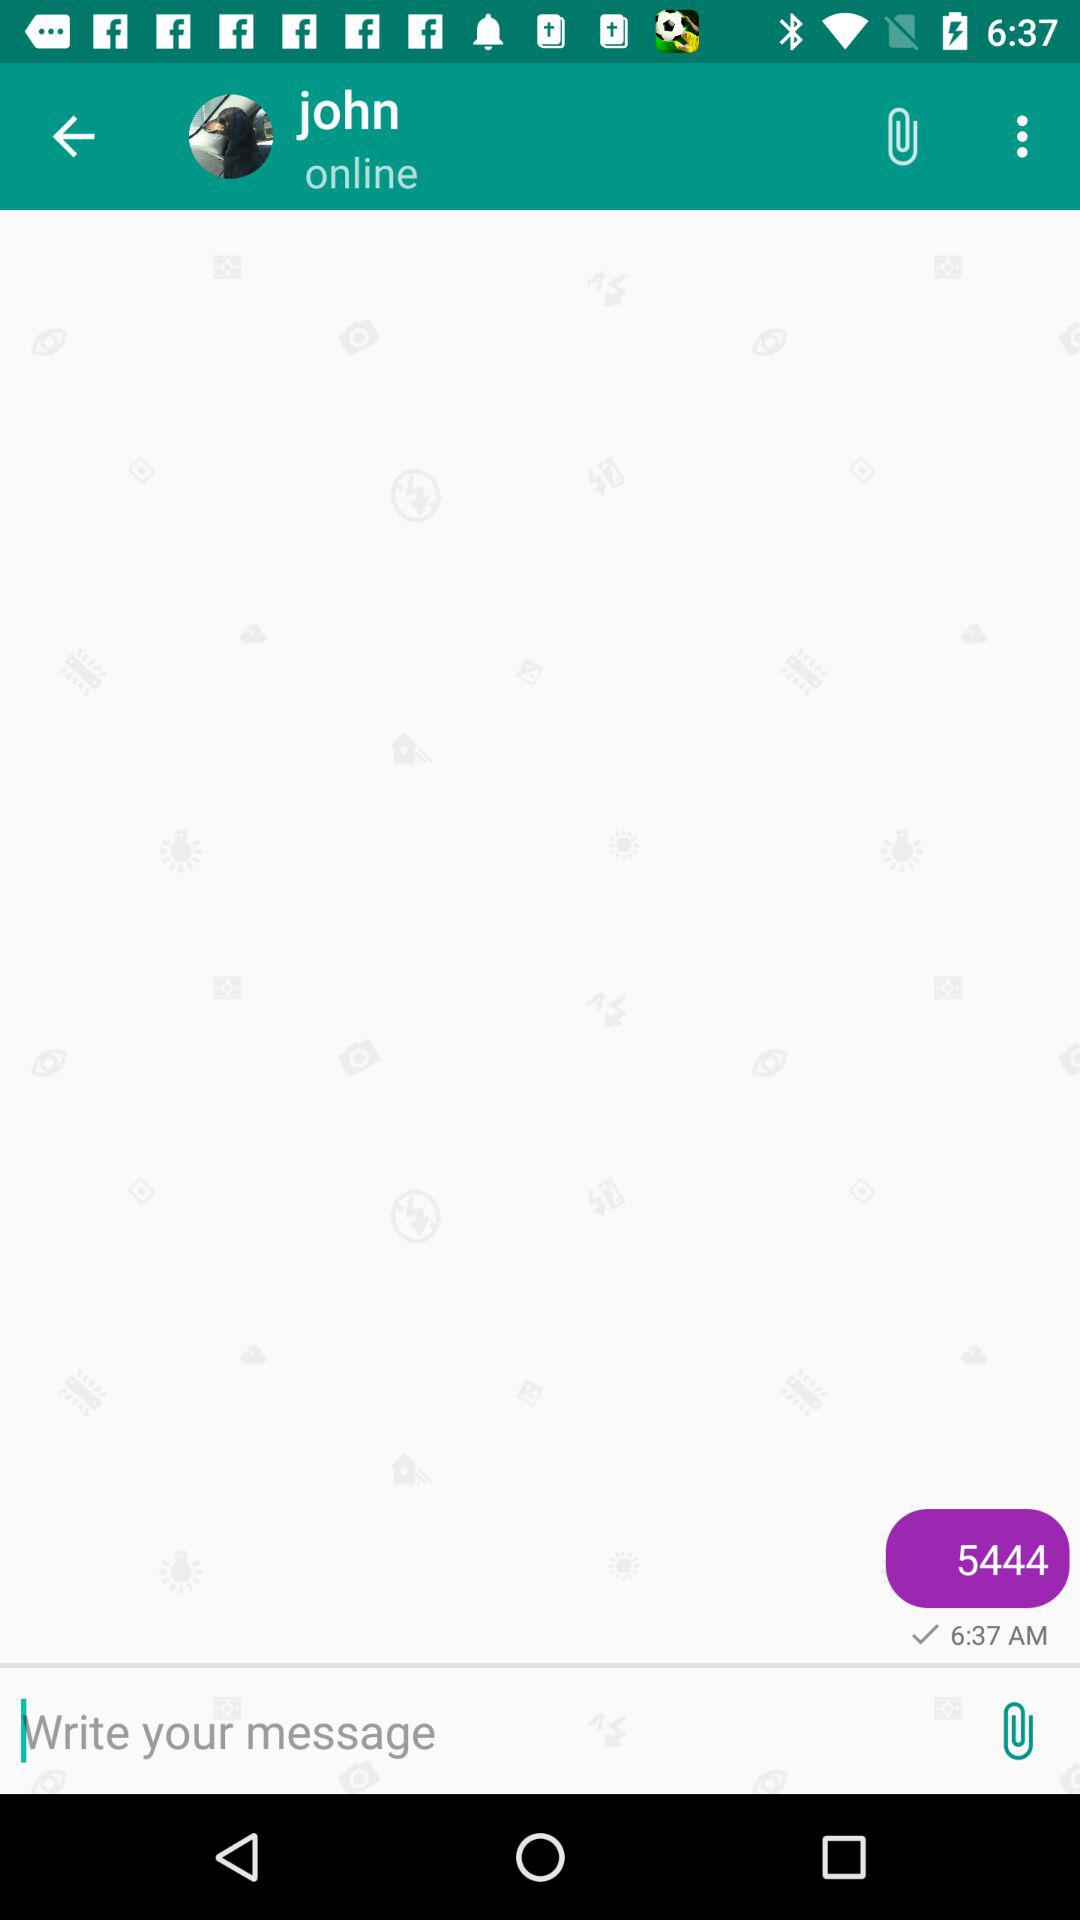At what time did I send the last message? The time was 6:37 AM. 